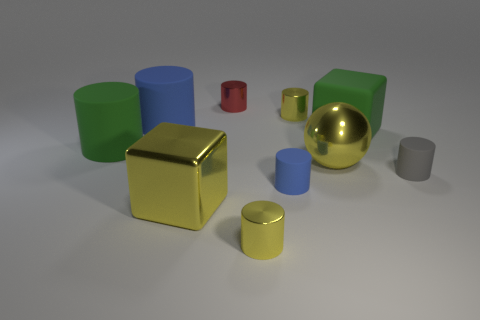There is a large yellow metallic thing that is in front of the small gray rubber cylinder; what is its shape?
Your answer should be very brief. Cube. Are the big sphere and the yellow object behind the big green cylinder made of the same material?
Provide a succinct answer. Yes. Are there any small red matte balls?
Offer a terse response. No. There is a tiny metallic object that is left of the shiny cylinder that is in front of the green block; is there a tiny matte cylinder behind it?
Ensure brevity in your answer.  No. How many large things are red matte cylinders or green cubes?
Your response must be concise. 1. What color is the other cube that is the same size as the yellow cube?
Your answer should be very brief. Green. There is a red metal thing; how many big green cylinders are on the right side of it?
Provide a succinct answer. 0. Is there a big gray cylinder that has the same material as the sphere?
Your answer should be very brief. No. What is the shape of the large thing that is the same color as the large metal cube?
Ensure brevity in your answer.  Sphere. There is a metal thing that is in front of the yellow block; what color is it?
Your answer should be compact. Yellow. 